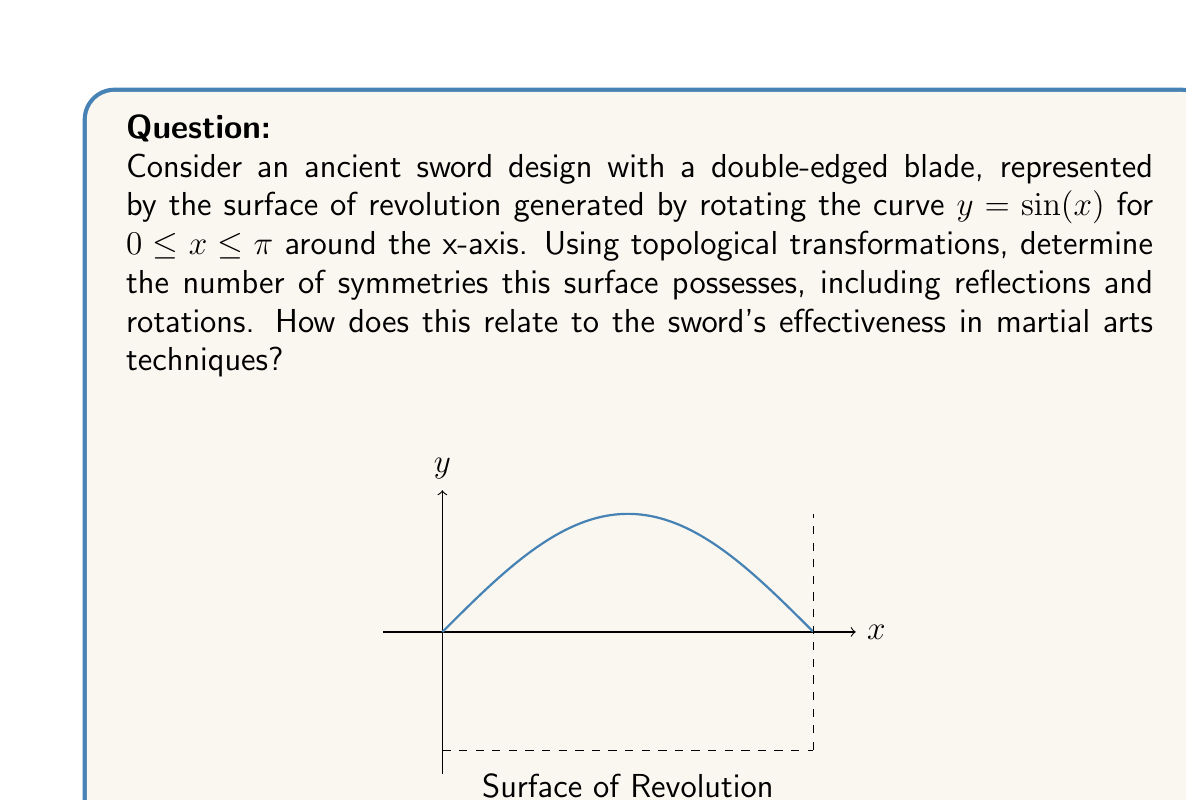Can you answer this question? Let's approach this step-by-step:

1) First, we need to understand the surface we're dealing with. The surface of revolution is created by rotating the curve $y = \sin(x)$ for $0 \leq x \leq \pi$ around the x-axis. This creates a symmetric, spindle-like shape.

2) To analyze the symmetries, we need to consider both rotational and reflectional symmetries:

   a) Rotational symmetry: The surface has infinite rotational symmetry around the x-axis. Any rotation around this axis will produce an identical surface.

   b) Reflectional symmetry: There are two planes of reflection symmetry:
      - The yz-plane (x = π/2)
      - Any plane containing the x-axis

3) In terms of topological transformations, these symmetries can be described as:
   - Rotations: $R_\theta: (x, y, z) \mapsto (x, y\cos\theta - z\sin\theta, y\sin\theta + z\cos\theta)$ for any $\theta$
   - Reflection in yz-plane: $F_1: (x, y, z) \mapsto (\pi - x, y, z)$
   - Reflection in any plane containing x-axis: $F_2: (x, y, z) \mapsto (x, y\cos\phi - z\sin\phi, y\sin\phi + z\cos\phi)$ for any $\phi$

4) The total number of symmetries is infinite due to the rotational symmetry. However, we typically classify this as having 2 types of symmetry operations (rotation and reflection) with infinite instances of each.

5) Relating to martial arts techniques:
   - The rotational symmetry allows for equal effectiveness when striking from any angle around the blade's axis.
   - The reflectional symmetry ensures balance, allowing for ambidextrous use and consistent performance in both forward and backward slashing motions.
   - The symmetry at x = π/2 creates a balanced center of mass, crucial for swift and precise movements in martial arts forms.
Answer: Infinite symmetries: ∞ rotations around x-axis, 2 types of reflections (yz-plane and planes containing x-axis). 